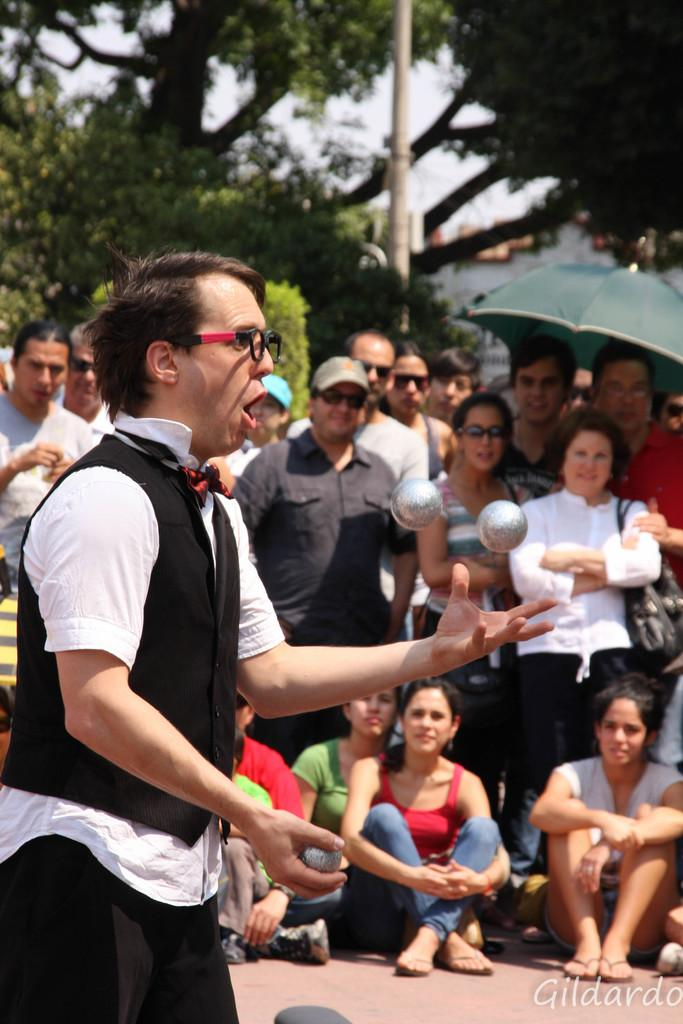What is the person in the foreground of the image holding? The person is holding balls in the foreground of the image. What can be seen in the middle of the image? There are people in the middle of the image. What type of natural elements are visible in the background of the image? There are trees and plants in the background of the image. What type of man-made structures can be seen in the background of the image? There are buildings in the background of the image. What part of the natural environment is visible in the background of the image? The sky is visible in the background of the image. Can you see any fangs or cobwebs in the image? No, there are no fangs or cobwebs present in the image. Is there a cellar visible in the image? No, there is no cellar visible in the image. 